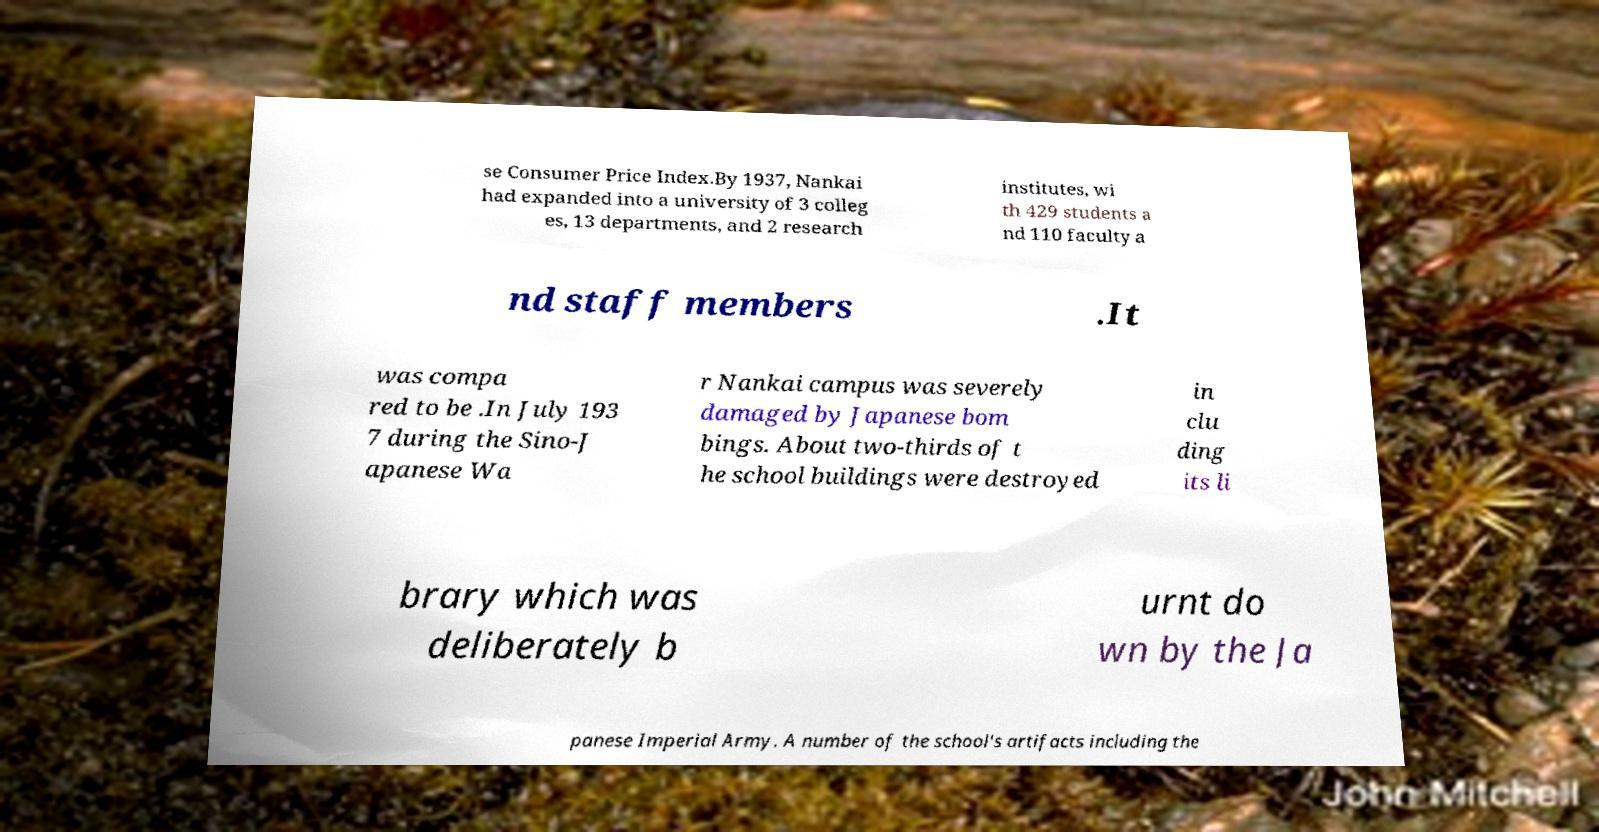Could you assist in decoding the text presented in this image and type it out clearly? se Consumer Price Index.By 1937, Nankai had expanded into a university of 3 colleg es, 13 departments, and 2 research institutes, wi th 429 students a nd 110 faculty a nd staff members .It was compa red to be .In July 193 7 during the Sino-J apanese Wa r Nankai campus was severely damaged by Japanese bom bings. About two-thirds of t he school buildings were destroyed in clu ding its li brary which was deliberately b urnt do wn by the Ja panese Imperial Army. A number of the school's artifacts including the 